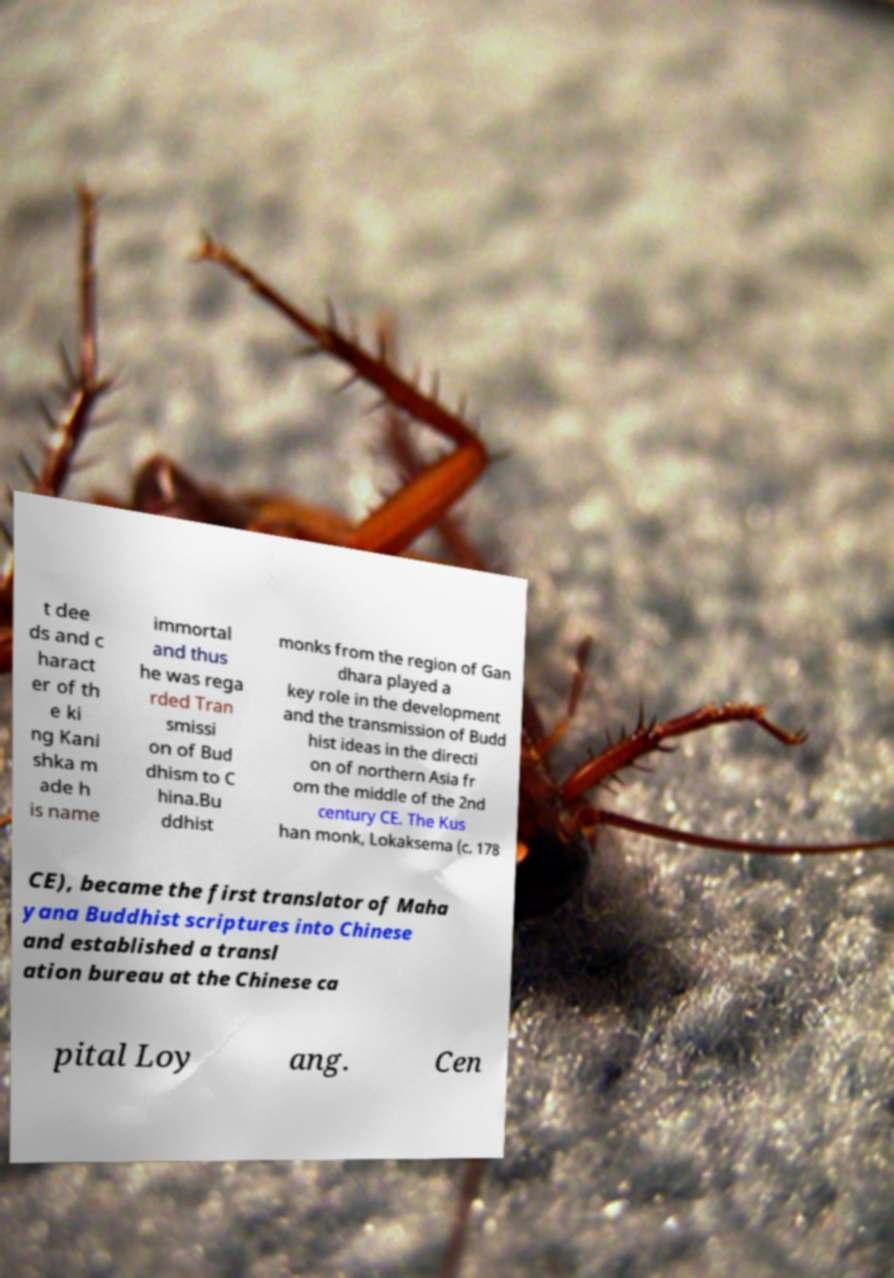Can you accurately transcribe the text from the provided image for me? t dee ds and c haract er of th e ki ng Kani shka m ade h is name immortal and thus he was rega rded Tran smissi on of Bud dhism to C hina.Bu ddhist monks from the region of Gan dhara played a key role in the development and the transmission of Budd hist ideas in the directi on of northern Asia fr om the middle of the 2nd century CE. The Kus han monk, Lokaksema (c. 178 CE), became the first translator of Maha yana Buddhist scriptures into Chinese and established a transl ation bureau at the Chinese ca pital Loy ang. Cen 